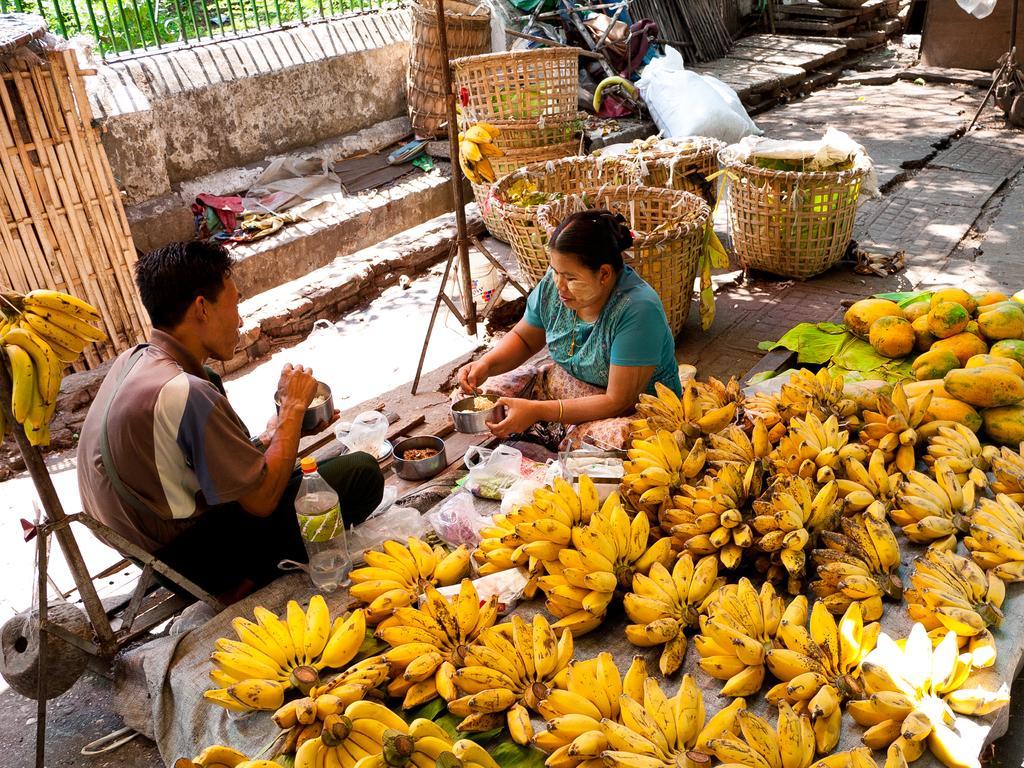Describe this image in one or two sentences. In the image,there are a lot of bananas and papayas are kept on the floor. Beside them a man and woman are having food,behind them there are wooden baskets and some other items. 